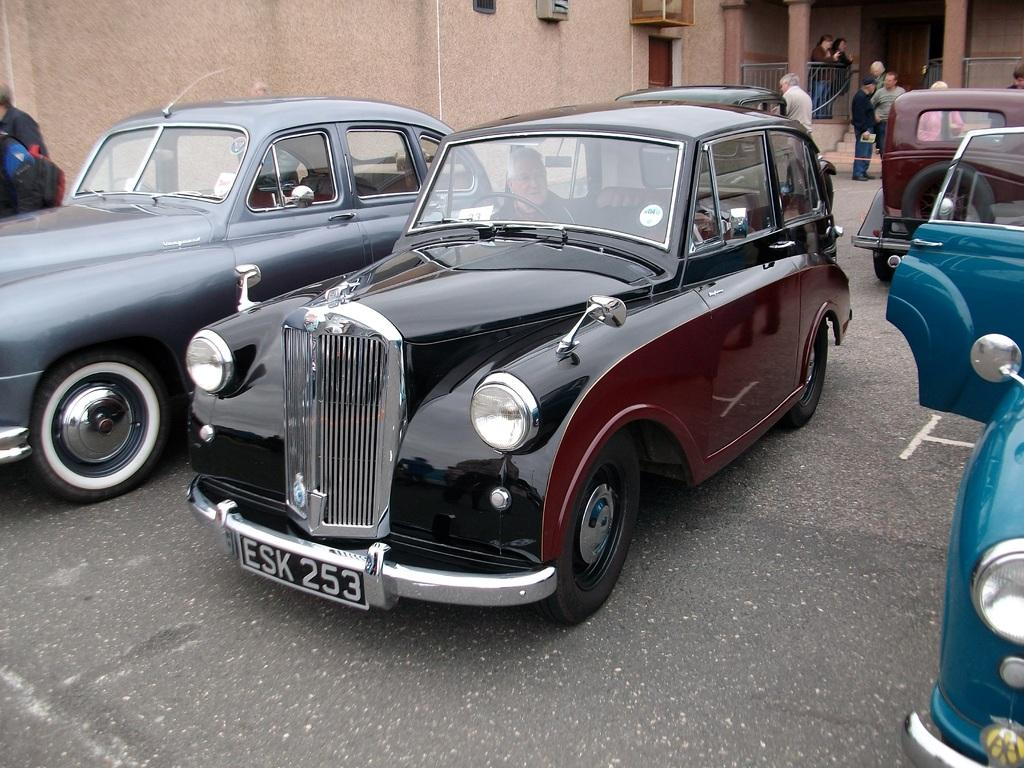What is the person in the image doing? There is a person sitting in a car in the image. What else can be seen on the ground in the image? There are vehicles on the ground in the image. Are there any other people visible in the image? Yes, there are people visible in the image. What can be seen in the background of the image? There is a building in the background of the image. What type of stone can be seen in the image? There is no stone present in the image. Are there any dinosaurs visible in the image? No, there are no dinosaurs present in the image. 